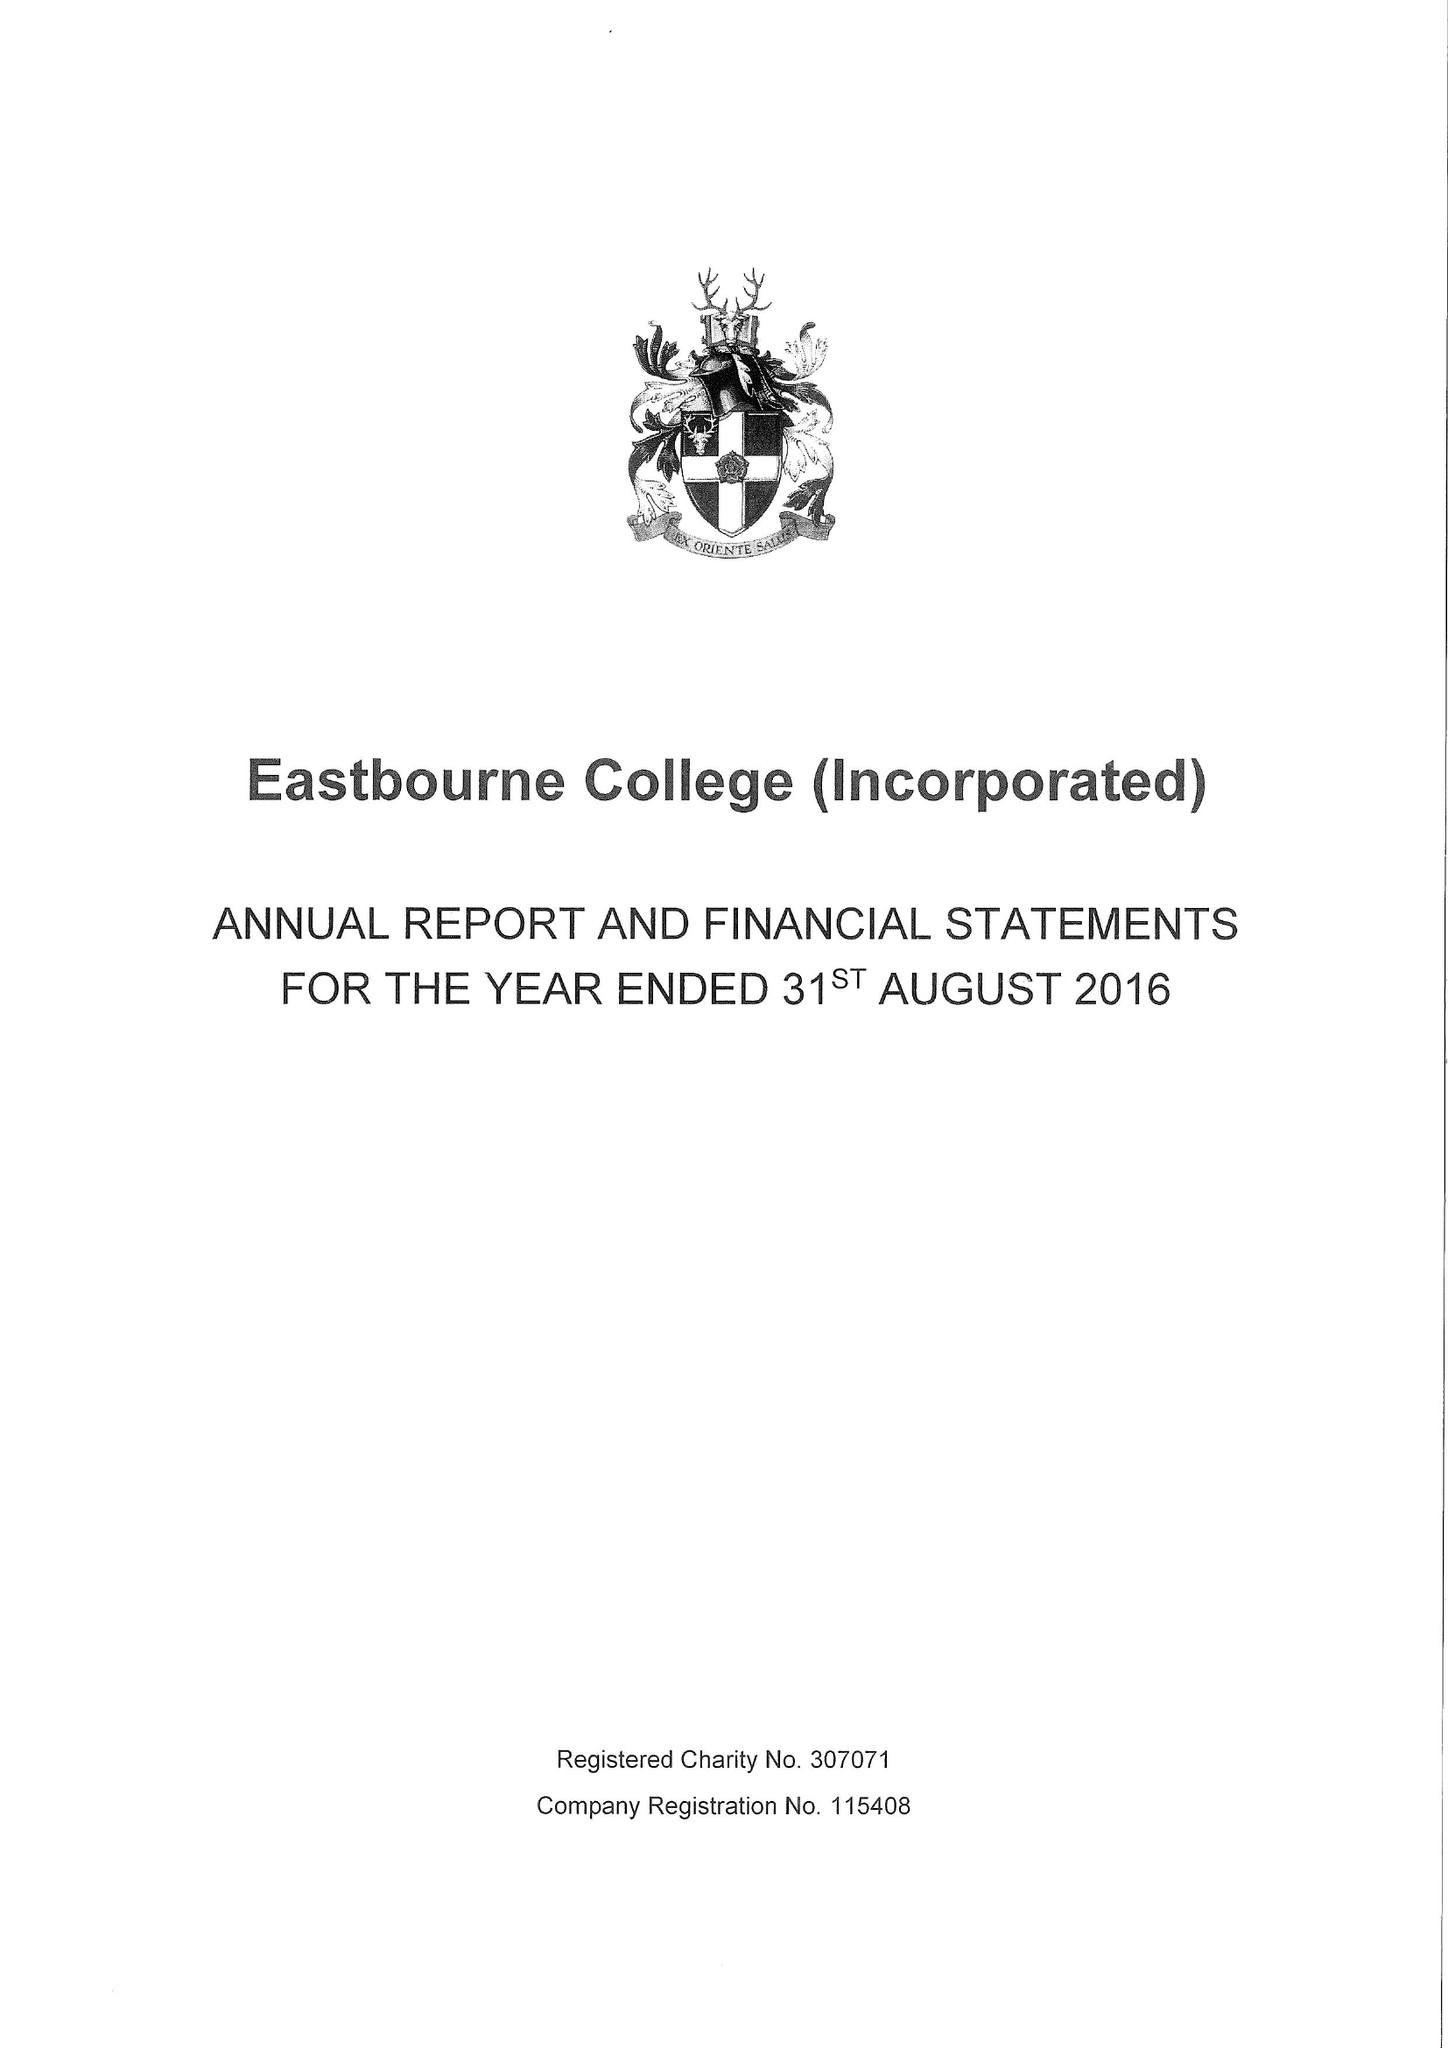What is the value for the charity_number?
Answer the question using a single word or phrase. 307071 